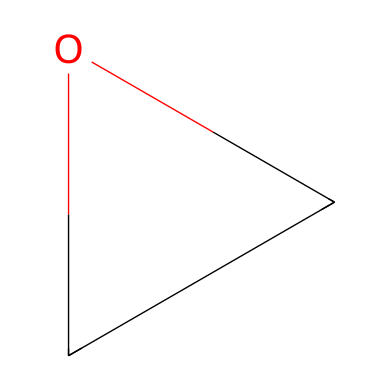What is the molecular formula of this epoxide? The structure consists of two carbon atoms and one oxygen atom, resulting in a molecular formula of C2H4O.
Answer: C2H4O How many rings are present in this structure? The structure contains one three-membered ring, which is characteristic of epoxides.
Answer: 1 What type of ring is formed by the atoms in this structure? The arrangement of the atoms, with three members (two carbons and one oxygen), forms a cyclic ether ring, specifically an epoxide.
Answer: cyclic ether What is the bond angle in a typical epoxide? The bond angles in a three-membered cyclic ether, such as an epoxide, are approximately 60 degrees due to the constraints of the ring structure.
Answer: 60 degrees What property makes epoxides reactive in organic synthesis? The significant strain in the three-membered ring increases its reactivity, making epoxides useful intermediates in various organic reactions.
Answer: ring strain Which functional group does this structure represent? The presence of the three-membered ring with an oxygen atom indicates that this is an epoxide, a type of cyclic ether.
Answer: epoxide 